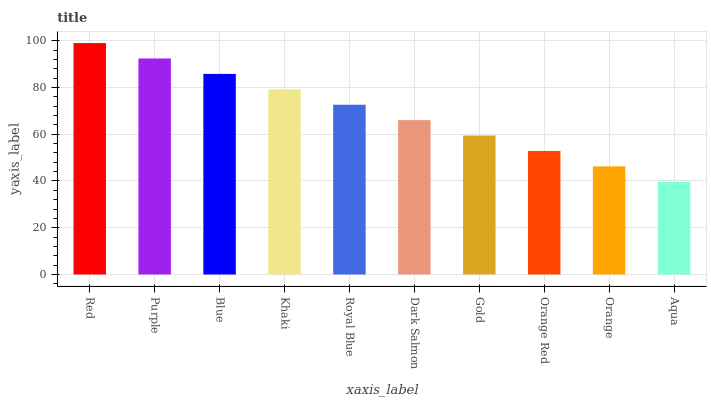Is Aqua the minimum?
Answer yes or no. Yes. Is Red the maximum?
Answer yes or no. Yes. Is Purple the minimum?
Answer yes or no. No. Is Purple the maximum?
Answer yes or no. No. Is Red greater than Purple?
Answer yes or no. Yes. Is Purple less than Red?
Answer yes or no. Yes. Is Purple greater than Red?
Answer yes or no. No. Is Red less than Purple?
Answer yes or no. No. Is Royal Blue the high median?
Answer yes or no. Yes. Is Dark Salmon the low median?
Answer yes or no. Yes. Is Aqua the high median?
Answer yes or no. No. Is Red the low median?
Answer yes or no. No. 